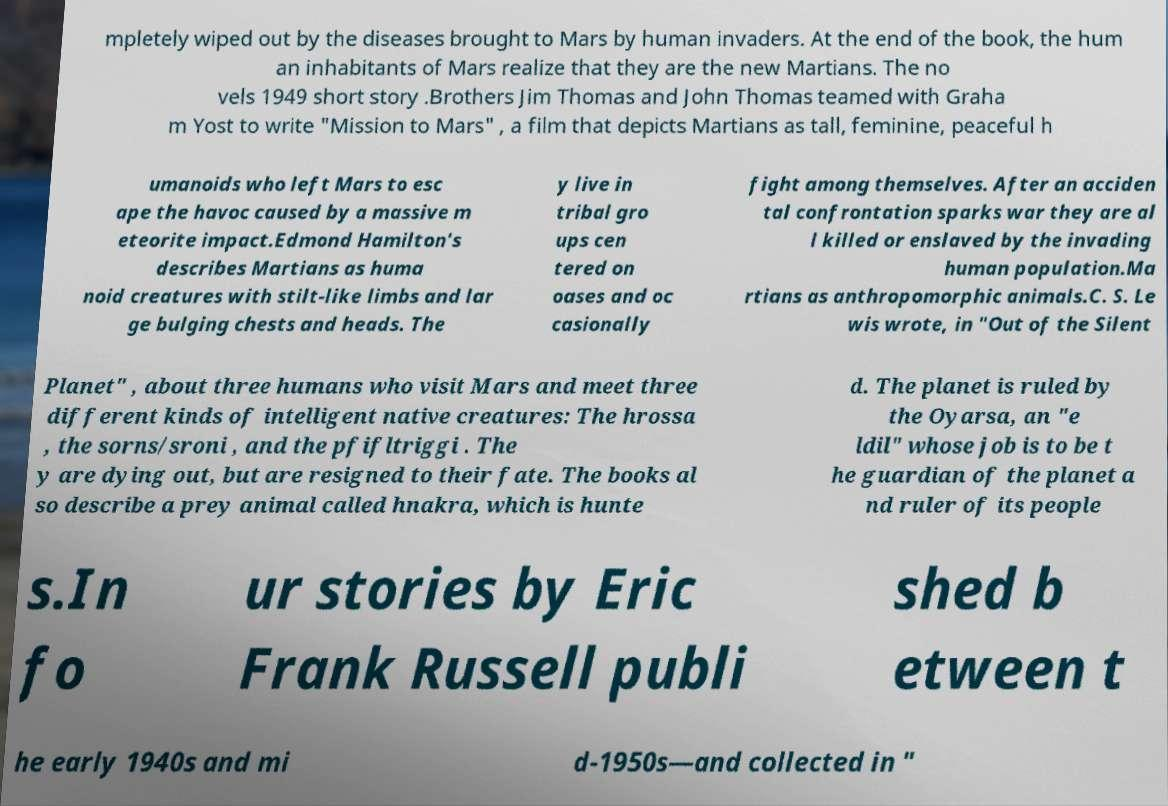There's text embedded in this image that I need extracted. Can you transcribe it verbatim? mpletely wiped out by the diseases brought to Mars by human invaders. At the end of the book, the hum an inhabitants of Mars realize that they are the new Martians. The no vels 1949 short story .Brothers Jim Thomas and John Thomas teamed with Graha m Yost to write "Mission to Mars" , a film that depicts Martians as tall, feminine, peaceful h umanoids who left Mars to esc ape the havoc caused by a massive m eteorite impact.Edmond Hamilton's describes Martians as huma noid creatures with stilt-like limbs and lar ge bulging chests and heads. The y live in tribal gro ups cen tered on oases and oc casionally fight among themselves. After an acciden tal confrontation sparks war they are al l killed or enslaved by the invading human population.Ma rtians as anthropomorphic animals.C. S. Le wis wrote, in "Out of the Silent Planet" , about three humans who visit Mars and meet three different kinds of intelligent native creatures: The hrossa , the sorns/sroni , and the pfifltriggi . The y are dying out, but are resigned to their fate. The books al so describe a prey animal called hnakra, which is hunte d. The planet is ruled by the Oyarsa, an "e ldil" whose job is to be t he guardian of the planet a nd ruler of its people s.In fo ur stories by Eric Frank Russell publi shed b etween t he early 1940s and mi d-1950s—and collected in " 